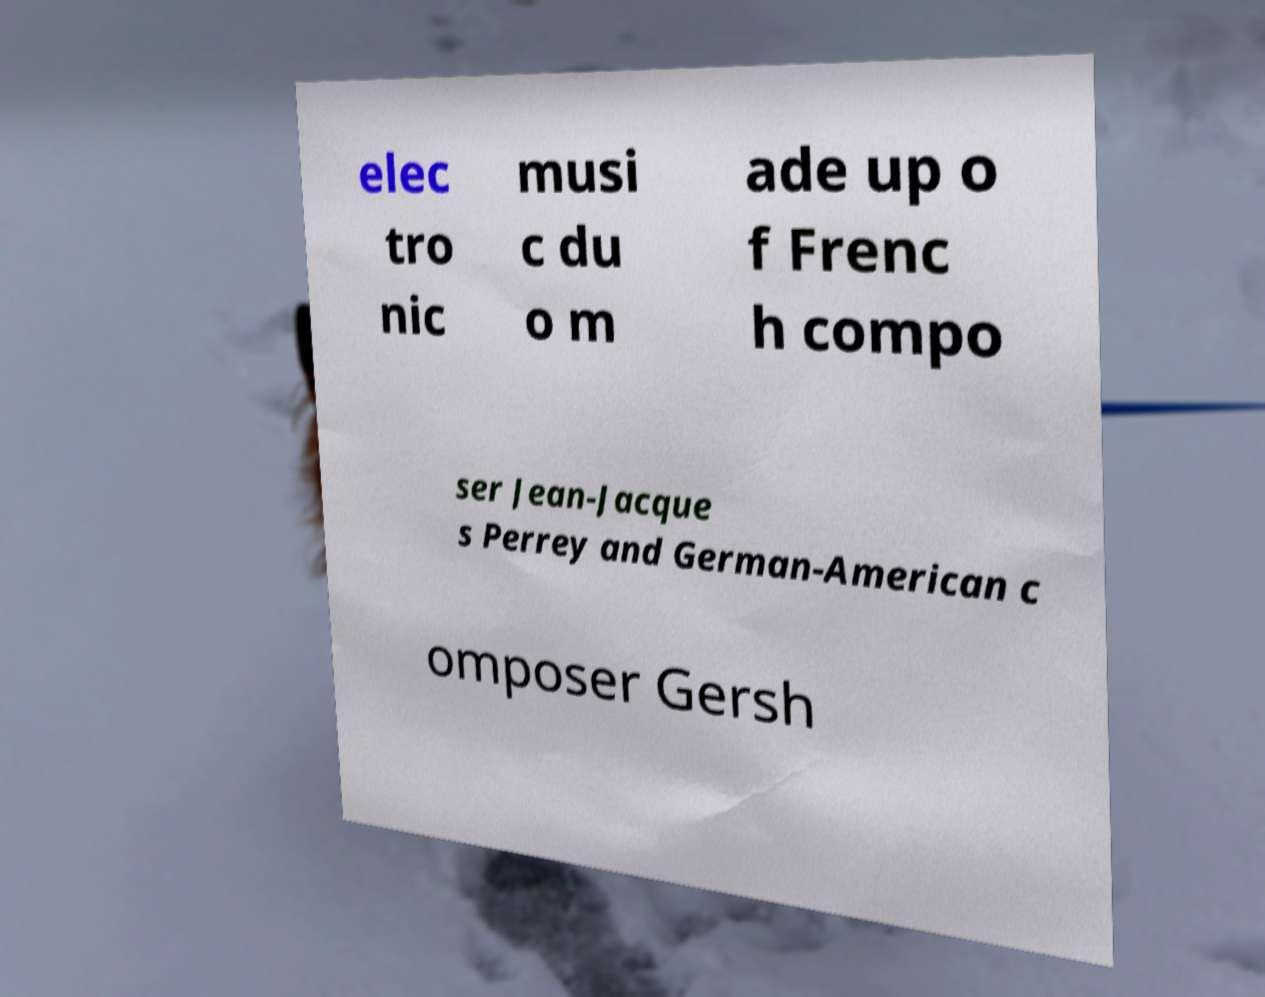Please identify and transcribe the text found in this image. elec tro nic musi c du o m ade up o f Frenc h compo ser Jean-Jacque s Perrey and German-American c omposer Gersh 